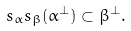<formula> <loc_0><loc_0><loc_500><loc_500>s _ { \alpha } s _ { \beta } ( \alpha ^ { \perp } ) \subset \beta ^ { \perp } .</formula> 